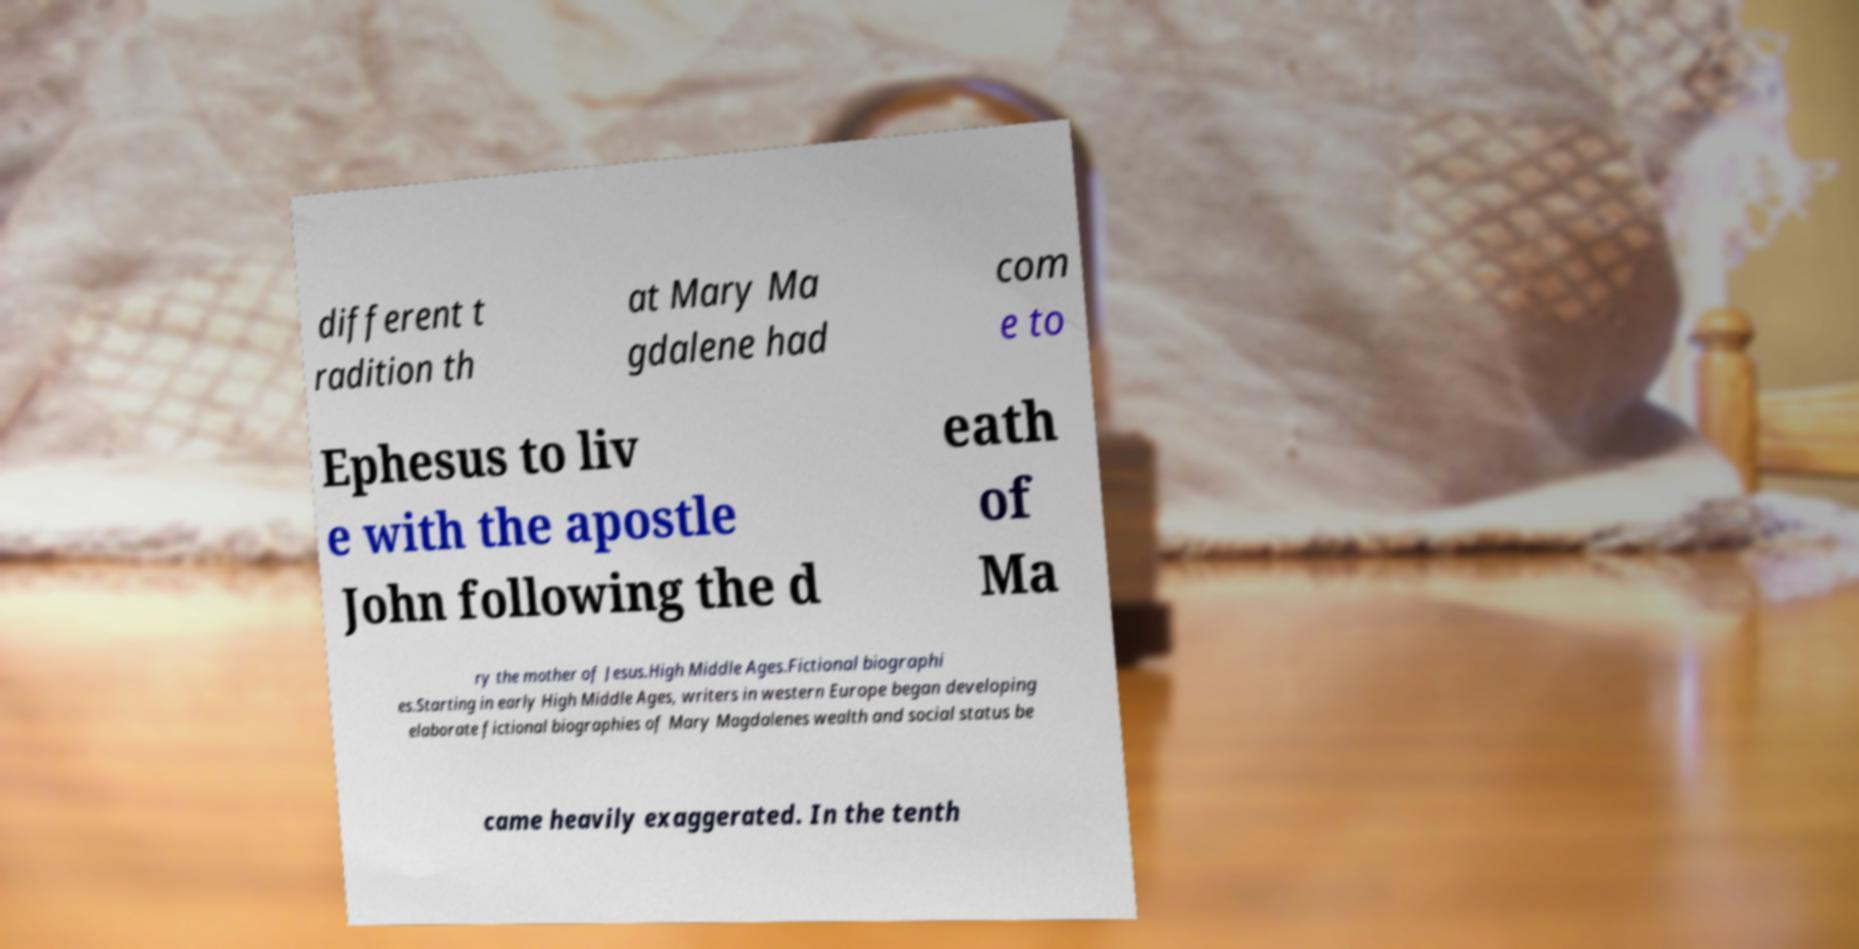What messages or text are displayed in this image? I need them in a readable, typed format. different t radition th at Mary Ma gdalene had com e to Ephesus to liv e with the apostle John following the d eath of Ma ry the mother of Jesus.High Middle Ages.Fictional biographi es.Starting in early High Middle Ages, writers in western Europe began developing elaborate fictional biographies of Mary Magdalenes wealth and social status be came heavily exaggerated. In the tenth 